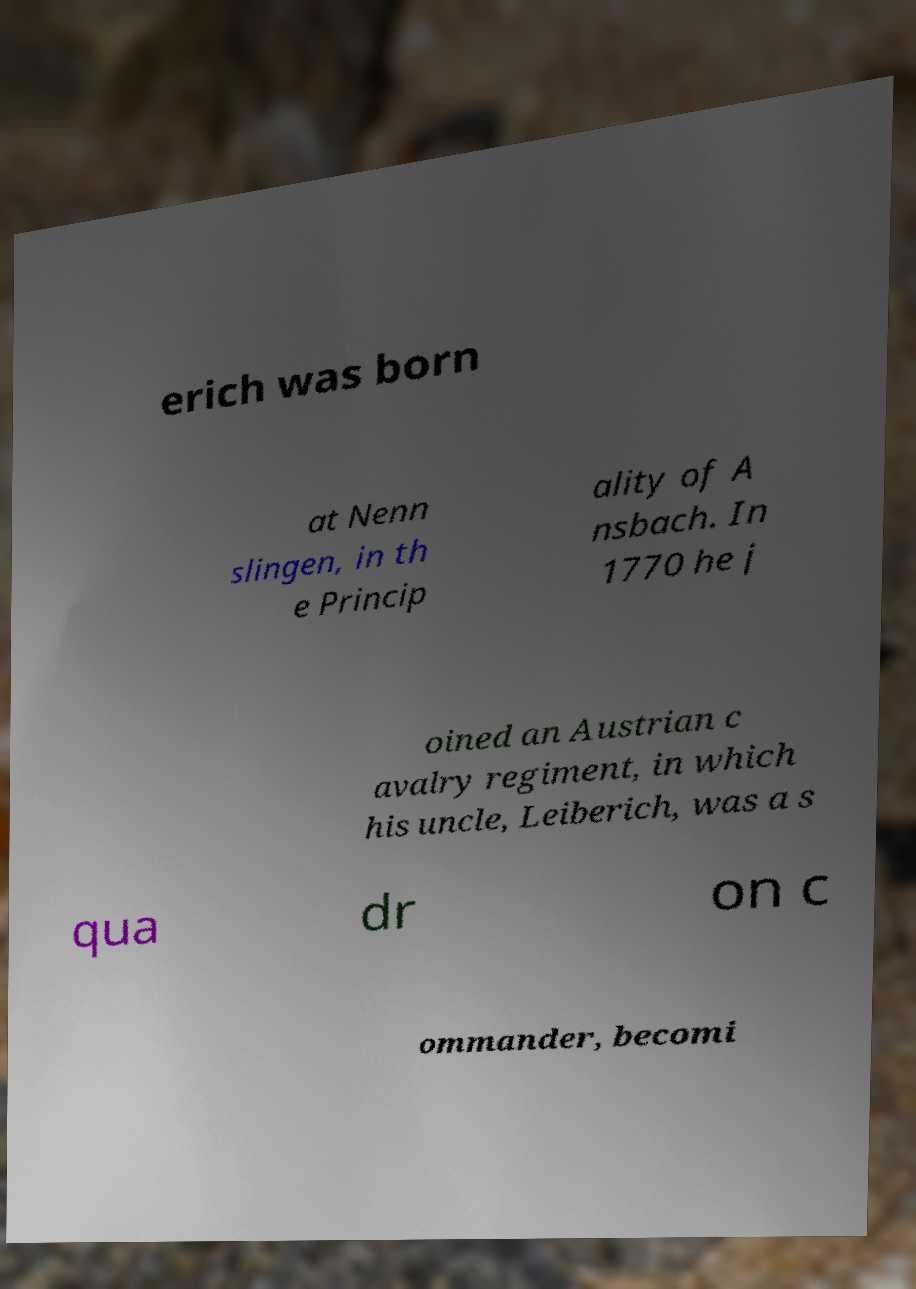Could you assist in decoding the text presented in this image and type it out clearly? erich was born at Nenn slingen, in th e Princip ality of A nsbach. In 1770 he j oined an Austrian c avalry regiment, in which his uncle, Leiberich, was a s qua dr on c ommander, becomi 